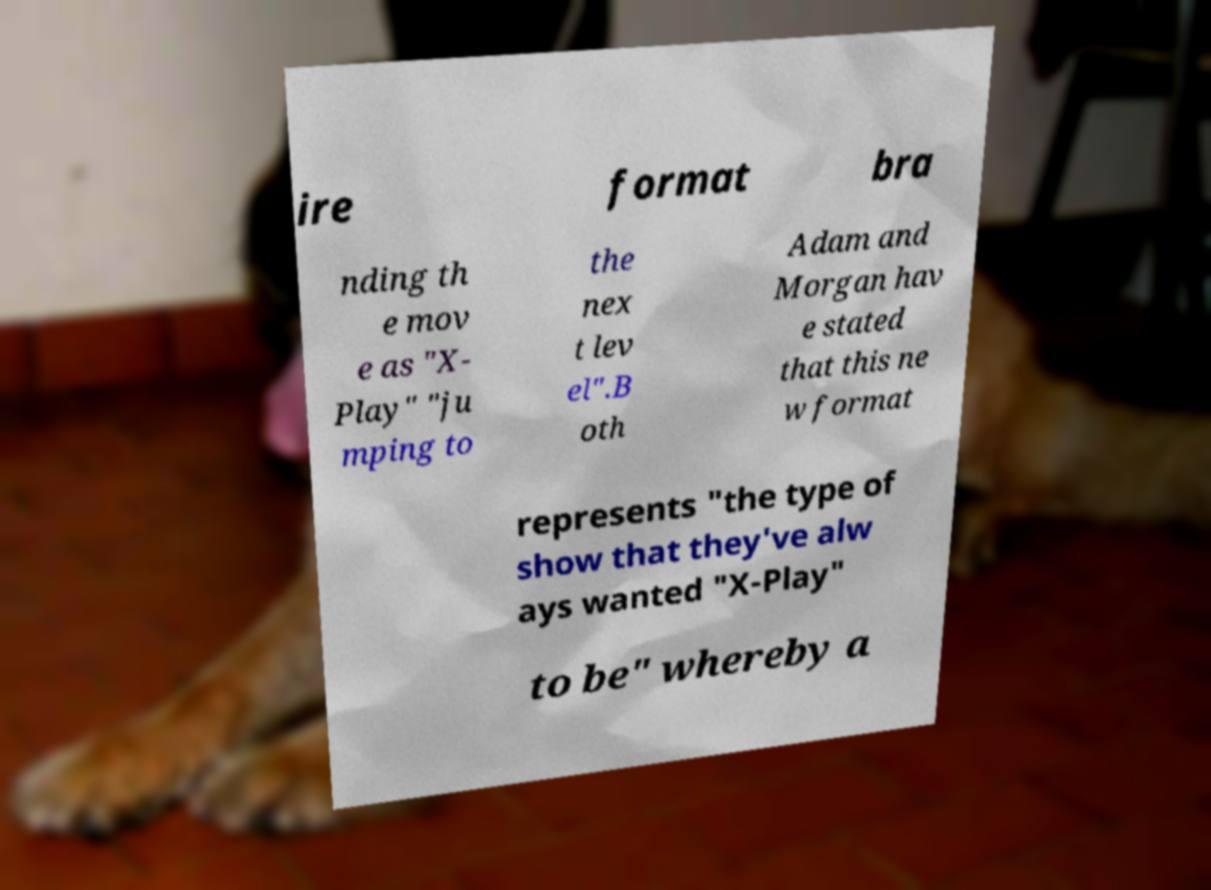What messages or text are displayed in this image? I need them in a readable, typed format. ire format bra nding th e mov e as "X- Play" "ju mping to the nex t lev el".B oth Adam and Morgan hav e stated that this ne w format represents "the type of show that they've alw ays wanted "X-Play" to be" whereby a 